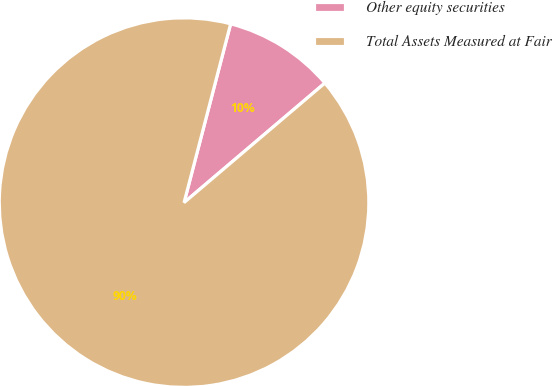Convert chart to OTSL. <chart><loc_0><loc_0><loc_500><loc_500><pie_chart><fcel>Other equity securities<fcel>Total Assets Measured at Fair<nl><fcel>9.74%<fcel>90.26%<nl></chart> 